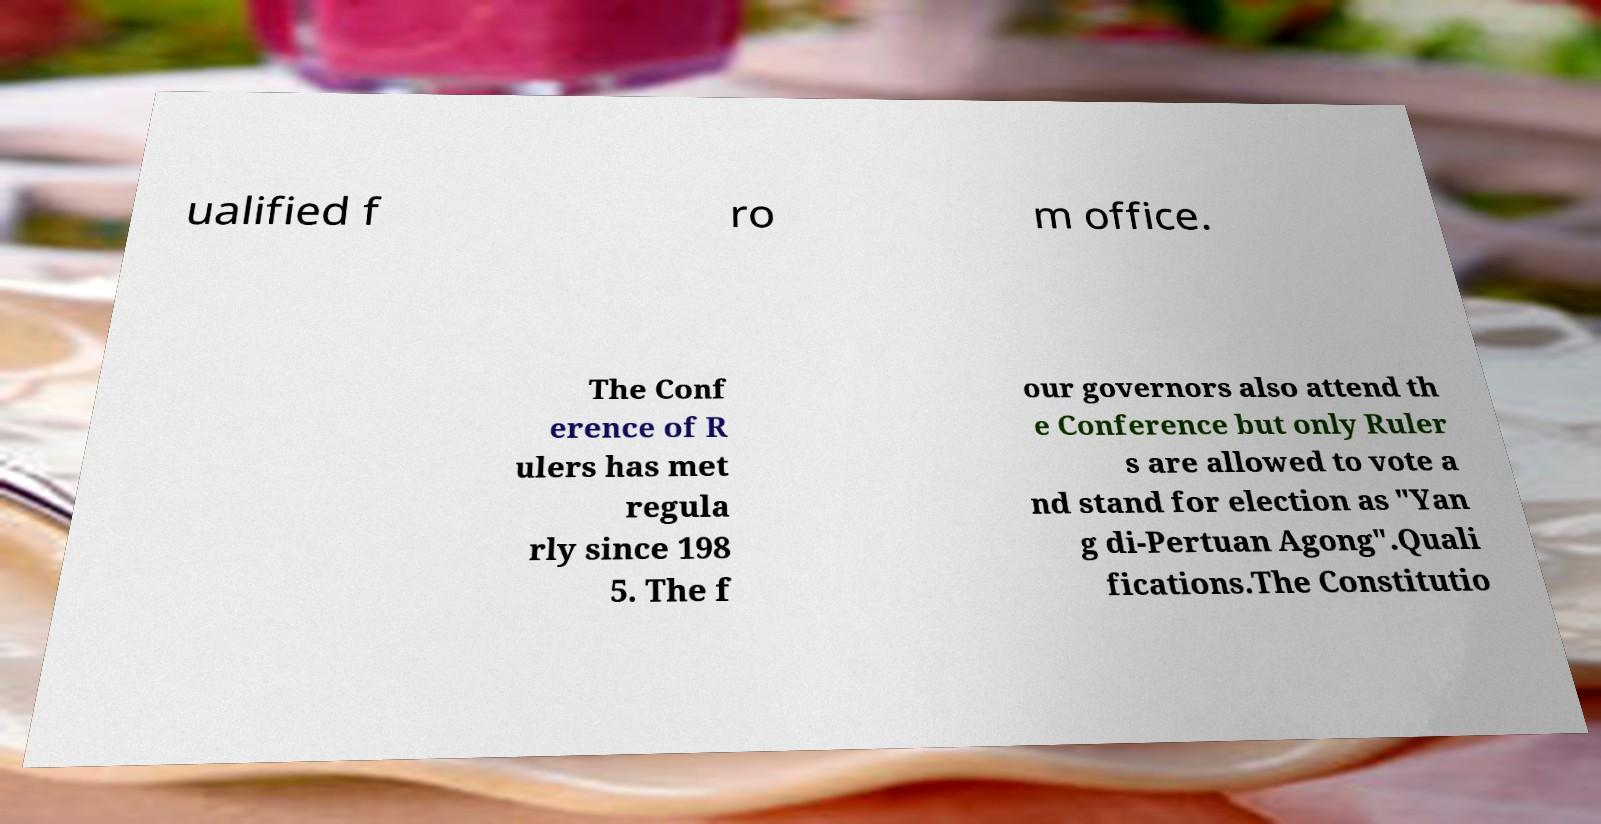There's text embedded in this image that I need extracted. Can you transcribe it verbatim? ualified f ro m office. The Conf erence of R ulers has met regula rly since 198 5. The f our governors also attend th e Conference but only Ruler s are allowed to vote a nd stand for election as "Yan g di-Pertuan Agong".Quali fications.The Constitutio 